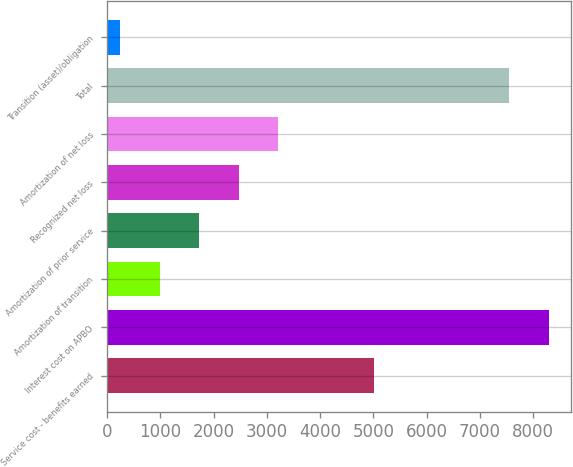<chart> <loc_0><loc_0><loc_500><loc_500><bar_chart><fcel>Service cost - benefits earned<fcel>Interest cost on APBO<fcel>Amortization of transition<fcel>Amortization of prior service<fcel>Recognized net loss<fcel>Amortization of net loss<fcel>Total<fcel>Transition (asset)/obligation<nl><fcel>5003<fcel>8298.9<fcel>981.9<fcel>1724.8<fcel>2467.7<fcel>3210.6<fcel>7556<fcel>239<nl></chart> 